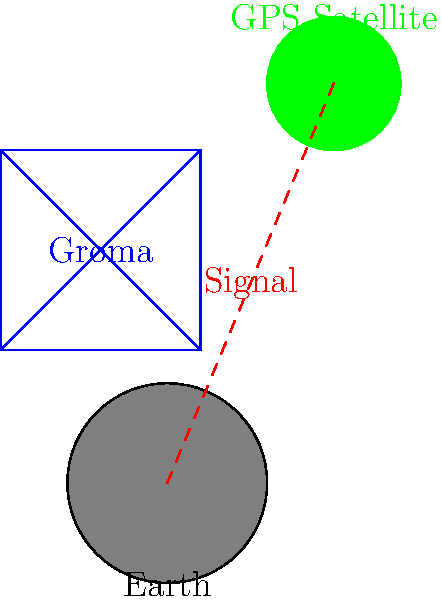Consider the ancient Roman surveying tool called a groma and modern GPS technology. If the accuracy of land surveying using a groma was approximately 1 meter per 100 meters measured, and a typical GPS receiver has an accuracy of about 5 meters, by what factor has the precision of land surveying improved from ancient to modern times? To solve this problem, we need to follow these steps:

1. Understand the given accuracies:
   - Groma: 1 meter per 100 meters measured
   - GPS: 5 meters (regardless of distance)

2. Convert the groma's accuracy to a percentage:
   $\frac{1 \text{ meter}}{100 \text{ meters}} = 0.01 = 1\%$

3. Convert the GPS accuracy to a percentage for comparison:
   We need to choose a distance for comparison. Let's use 100 meters to match the groma's measurement.
   $\frac{5 \text{ meters}}{100 \text{ meters}} = 0.05 = 5\%$

4. Compare the two percentages:
   Groma: 1%
   GPS: 5%

5. Calculate the improvement factor:
   $\frac{\text{Groma error}}{\text{GPS error}} = \frac{1\%}{5\%} = \frac{1}{5} = 0.2$

6. Interpret the result:
   The factor 0.2 means that the error has been reduced to 1/5 of its original value.
   To express this as an improvement, we take the reciprocal:
   $\frac{1}{0.2} = 5$

Therefore, the precision of land surveying has improved by a factor of 5 from ancient times to modern GPS technology.
Answer: 5 